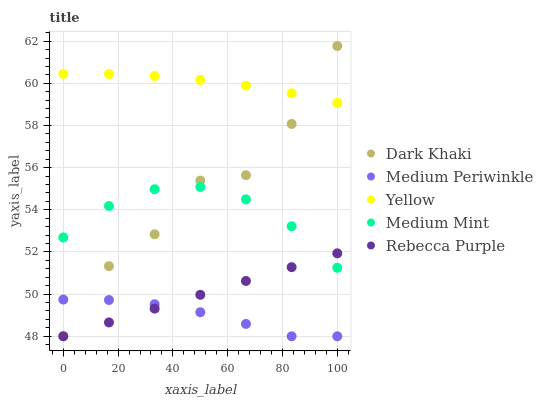Does Medium Periwinkle have the minimum area under the curve?
Answer yes or no. Yes. Does Yellow have the maximum area under the curve?
Answer yes or no. Yes. Does Medium Mint have the minimum area under the curve?
Answer yes or no. No. Does Medium Mint have the maximum area under the curve?
Answer yes or no. No. Is Rebecca Purple the smoothest?
Answer yes or no. Yes. Is Dark Khaki the roughest?
Answer yes or no. Yes. Is Medium Mint the smoothest?
Answer yes or no. No. Is Medium Mint the roughest?
Answer yes or no. No. Does Dark Khaki have the lowest value?
Answer yes or no. Yes. Does Medium Mint have the lowest value?
Answer yes or no. No. Does Dark Khaki have the highest value?
Answer yes or no. Yes. Does Medium Mint have the highest value?
Answer yes or no. No. Is Rebecca Purple less than Yellow?
Answer yes or no. Yes. Is Yellow greater than Medium Mint?
Answer yes or no. Yes. Does Medium Periwinkle intersect Dark Khaki?
Answer yes or no. Yes. Is Medium Periwinkle less than Dark Khaki?
Answer yes or no. No. Is Medium Periwinkle greater than Dark Khaki?
Answer yes or no. No. Does Rebecca Purple intersect Yellow?
Answer yes or no. No. 